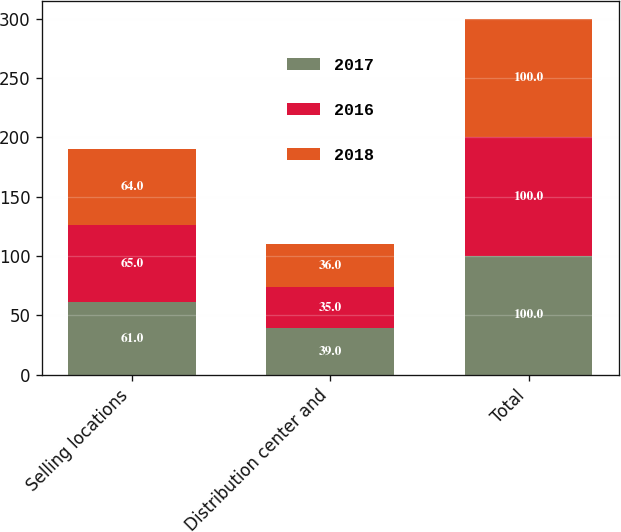<chart> <loc_0><loc_0><loc_500><loc_500><stacked_bar_chart><ecel><fcel>Selling locations<fcel>Distribution center and<fcel>Total<nl><fcel>2017<fcel>61<fcel>39<fcel>100<nl><fcel>2016<fcel>65<fcel>35<fcel>100<nl><fcel>2018<fcel>64<fcel>36<fcel>100<nl></chart> 